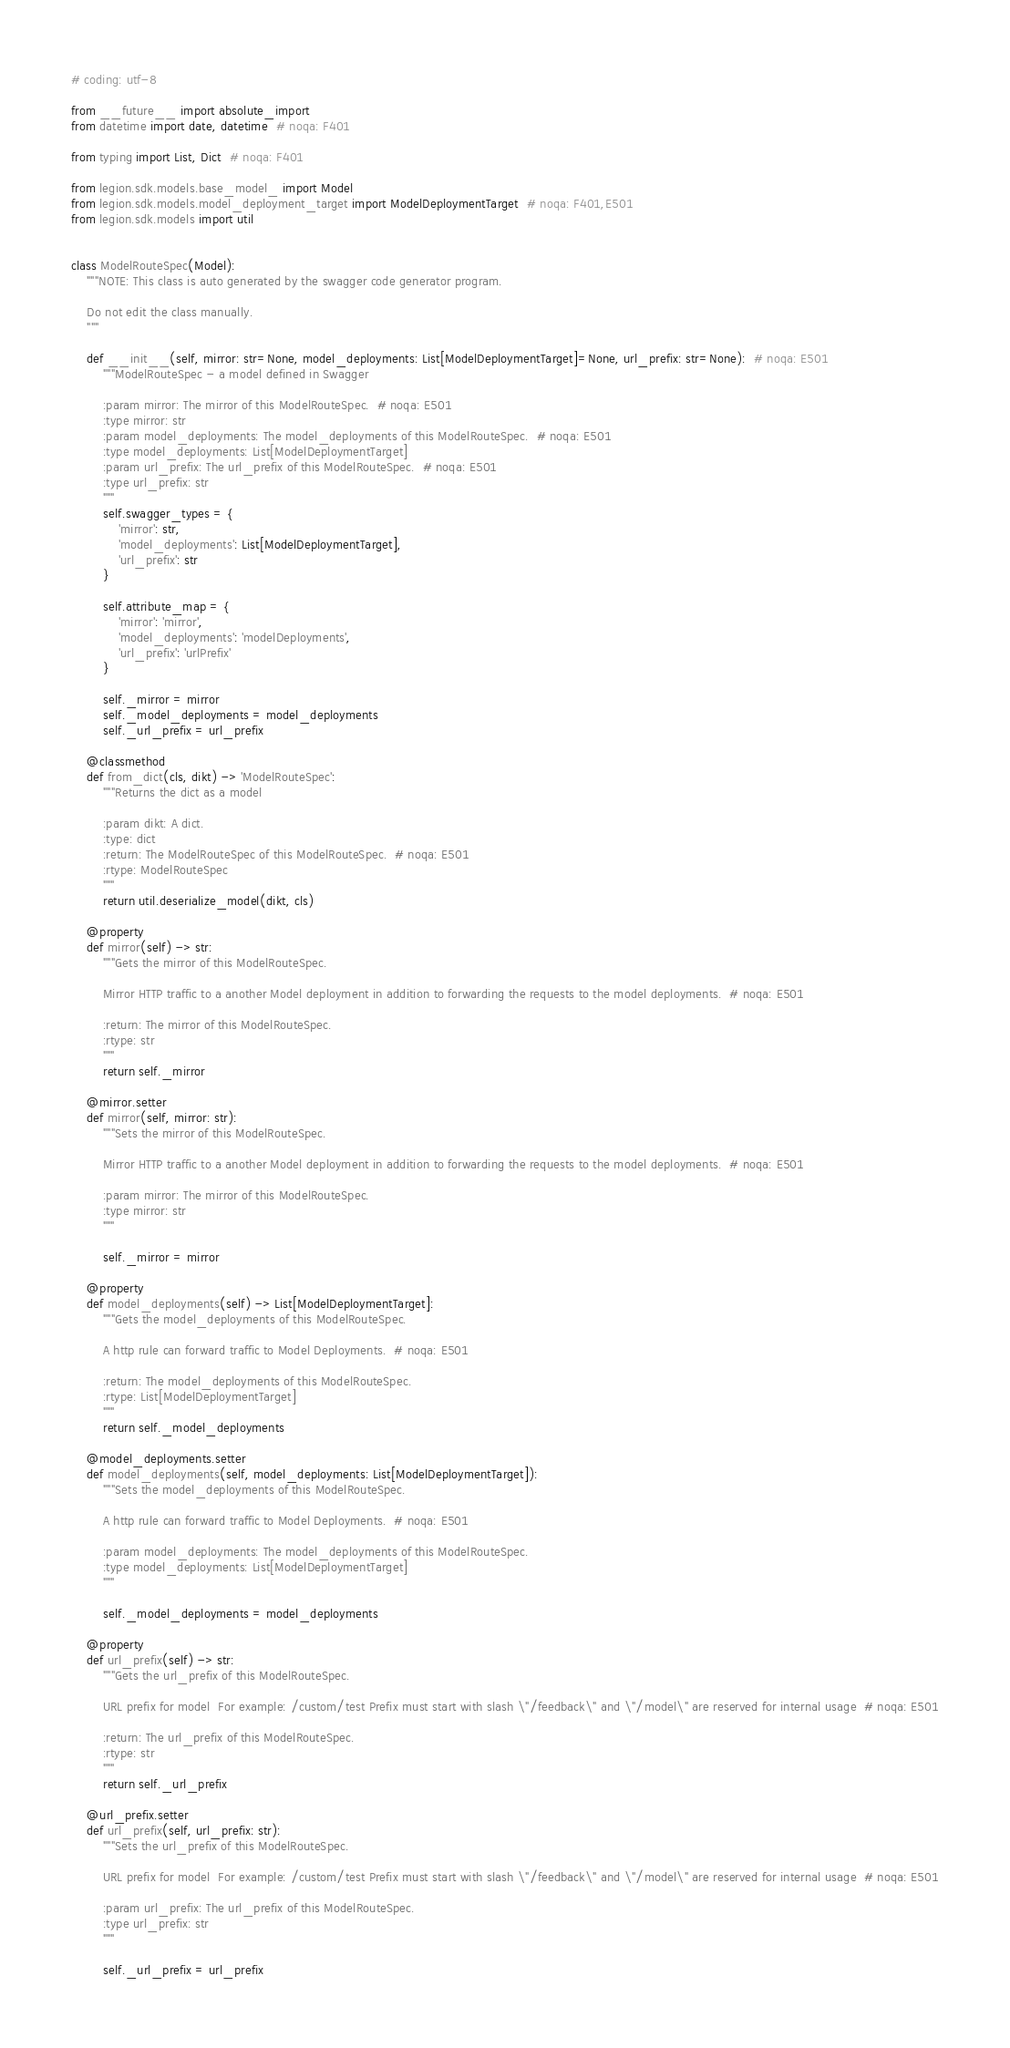Convert code to text. <code><loc_0><loc_0><loc_500><loc_500><_Python_># coding: utf-8

from __future__ import absolute_import
from datetime import date, datetime  # noqa: F401

from typing import List, Dict  # noqa: F401

from legion.sdk.models.base_model_ import Model
from legion.sdk.models.model_deployment_target import ModelDeploymentTarget  # noqa: F401,E501
from legion.sdk.models import util


class ModelRouteSpec(Model):
    """NOTE: This class is auto generated by the swagger code generator program.

    Do not edit the class manually.
    """

    def __init__(self, mirror: str=None, model_deployments: List[ModelDeploymentTarget]=None, url_prefix: str=None):  # noqa: E501
        """ModelRouteSpec - a model defined in Swagger

        :param mirror: The mirror of this ModelRouteSpec.  # noqa: E501
        :type mirror: str
        :param model_deployments: The model_deployments of this ModelRouteSpec.  # noqa: E501
        :type model_deployments: List[ModelDeploymentTarget]
        :param url_prefix: The url_prefix of this ModelRouteSpec.  # noqa: E501
        :type url_prefix: str
        """
        self.swagger_types = {
            'mirror': str,
            'model_deployments': List[ModelDeploymentTarget],
            'url_prefix': str
        }

        self.attribute_map = {
            'mirror': 'mirror',
            'model_deployments': 'modelDeployments',
            'url_prefix': 'urlPrefix'
        }

        self._mirror = mirror
        self._model_deployments = model_deployments
        self._url_prefix = url_prefix

    @classmethod
    def from_dict(cls, dikt) -> 'ModelRouteSpec':
        """Returns the dict as a model

        :param dikt: A dict.
        :type: dict
        :return: The ModelRouteSpec of this ModelRouteSpec.  # noqa: E501
        :rtype: ModelRouteSpec
        """
        return util.deserialize_model(dikt, cls)

    @property
    def mirror(self) -> str:
        """Gets the mirror of this ModelRouteSpec.

        Mirror HTTP traffic to a another Model deployment in addition to forwarding the requests to the model deployments.  # noqa: E501

        :return: The mirror of this ModelRouteSpec.
        :rtype: str
        """
        return self._mirror

    @mirror.setter
    def mirror(self, mirror: str):
        """Sets the mirror of this ModelRouteSpec.

        Mirror HTTP traffic to a another Model deployment in addition to forwarding the requests to the model deployments.  # noqa: E501

        :param mirror: The mirror of this ModelRouteSpec.
        :type mirror: str
        """

        self._mirror = mirror

    @property
    def model_deployments(self) -> List[ModelDeploymentTarget]:
        """Gets the model_deployments of this ModelRouteSpec.

        A http rule can forward traffic to Model Deployments.  # noqa: E501

        :return: The model_deployments of this ModelRouteSpec.
        :rtype: List[ModelDeploymentTarget]
        """
        return self._model_deployments

    @model_deployments.setter
    def model_deployments(self, model_deployments: List[ModelDeploymentTarget]):
        """Sets the model_deployments of this ModelRouteSpec.

        A http rule can forward traffic to Model Deployments.  # noqa: E501

        :param model_deployments: The model_deployments of this ModelRouteSpec.
        :type model_deployments: List[ModelDeploymentTarget]
        """

        self._model_deployments = model_deployments

    @property
    def url_prefix(self) -> str:
        """Gets the url_prefix of this ModelRouteSpec.

        URL prefix for model  For example: /custom/test Prefix must start with slash \"/feedback\" and \"/model\" are reserved for internal usage  # noqa: E501

        :return: The url_prefix of this ModelRouteSpec.
        :rtype: str
        """
        return self._url_prefix

    @url_prefix.setter
    def url_prefix(self, url_prefix: str):
        """Sets the url_prefix of this ModelRouteSpec.

        URL prefix for model  For example: /custom/test Prefix must start with slash \"/feedback\" and \"/model\" are reserved for internal usage  # noqa: E501

        :param url_prefix: The url_prefix of this ModelRouteSpec.
        :type url_prefix: str
        """

        self._url_prefix = url_prefix
</code> 